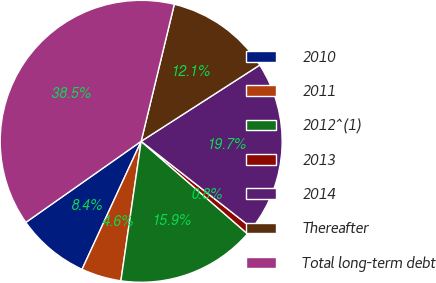Convert chart. <chart><loc_0><loc_0><loc_500><loc_500><pie_chart><fcel>2010<fcel>2011<fcel>2012^(1)<fcel>2013<fcel>2014<fcel>Thereafter<fcel>Total long-term debt<nl><fcel>8.36%<fcel>4.59%<fcel>15.9%<fcel>0.82%<fcel>19.67%<fcel>12.13%<fcel>38.53%<nl></chart> 